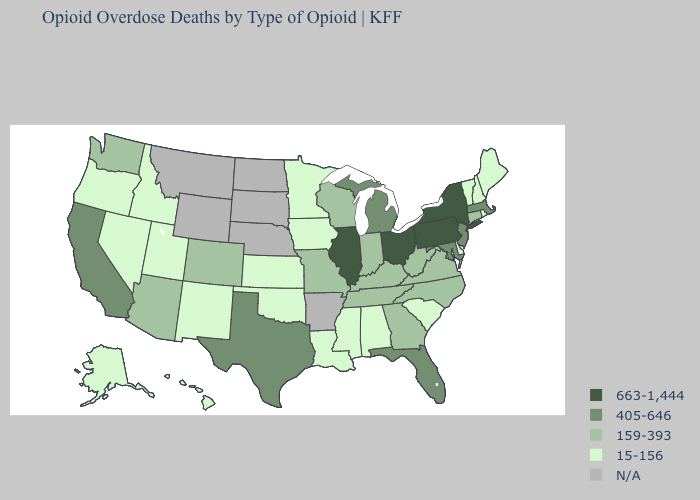What is the value of Utah?
Concise answer only. 15-156. Does Iowa have the highest value in the USA?
Concise answer only. No. Does the map have missing data?
Give a very brief answer. Yes. Name the states that have a value in the range 405-646?
Answer briefly. California, Florida, Maryland, Massachusetts, Michigan, New Jersey, Texas. What is the value of Maryland?
Be succinct. 405-646. Does the map have missing data?
Answer briefly. Yes. Does Wisconsin have the lowest value in the MidWest?
Quick response, please. No. Which states have the highest value in the USA?
Keep it brief. Illinois, New York, Ohio, Pennsylvania. What is the value of Illinois?
Write a very short answer. 663-1,444. Among the states that border Georgia , does Florida have the highest value?
Write a very short answer. Yes. Name the states that have a value in the range N/A?
Give a very brief answer. Arkansas, Montana, Nebraska, North Dakota, South Dakota, Wyoming. What is the value of Illinois?
Give a very brief answer. 663-1,444. What is the value of Pennsylvania?
Quick response, please. 663-1,444. Which states have the lowest value in the USA?
Write a very short answer. Alabama, Alaska, Delaware, Hawaii, Idaho, Iowa, Kansas, Louisiana, Maine, Minnesota, Mississippi, Nevada, New Hampshire, New Mexico, Oklahoma, Oregon, Rhode Island, South Carolina, Utah, Vermont. Name the states that have a value in the range 15-156?
Write a very short answer. Alabama, Alaska, Delaware, Hawaii, Idaho, Iowa, Kansas, Louisiana, Maine, Minnesota, Mississippi, Nevada, New Hampshire, New Mexico, Oklahoma, Oregon, Rhode Island, South Carolina, Utah, Vermont. 